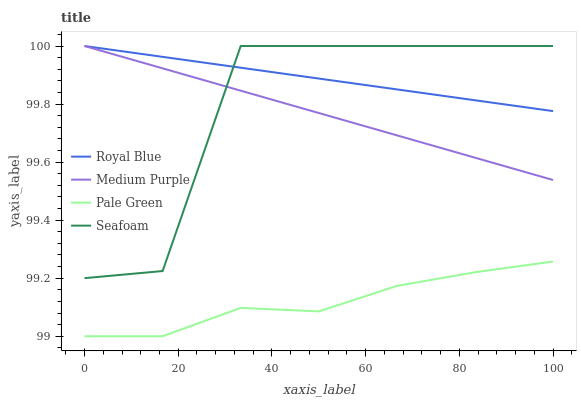Does Pale Green have the minimum area under the curve?
Answer yes or no. Yes. Does Royal Blue have the maximum area under the curve?
Answer yes or no. Yes. Does Royal Blue have the minimum area under the curve?
Answer yes or no. No. Does Pale Green have the maximum area under the curve?
Answer yes or no. No. Is Royal Blue the smoothest?
Answer yes or no. Yes. Is Seafoam the roughest?
Answer yes or no. Yes. Is Pale Green the smoothest?
Answer yes or no. No. Is Pale Green the roughest?
Answer yes or no. No. Does Pale Green have the lowest value?
Answer yes or no. Yes. Does Royal Blue have the lowest value?
Answer yes or no. No. Does Seafoam have the highest value?
Answer yes or no. Yes. Does Pale Green have the highest value?
Answer yes or no. No. Is Pale Green less than Royal Blue?
Answer yes or no. Yes. Is Seafoam greater than Pale Green?
Answer yes or no. Yes. Does Seafoam intersect Royal Blue?
Answer yes or no. Yes. Is Seafoam less than Royal Blue?
Answer yes or no. No. Is Seafoam greater than Royal Blue?
Answer yes or no. No. Does Pale Green intersect Royal Blue?
Answer yes or no. No. 